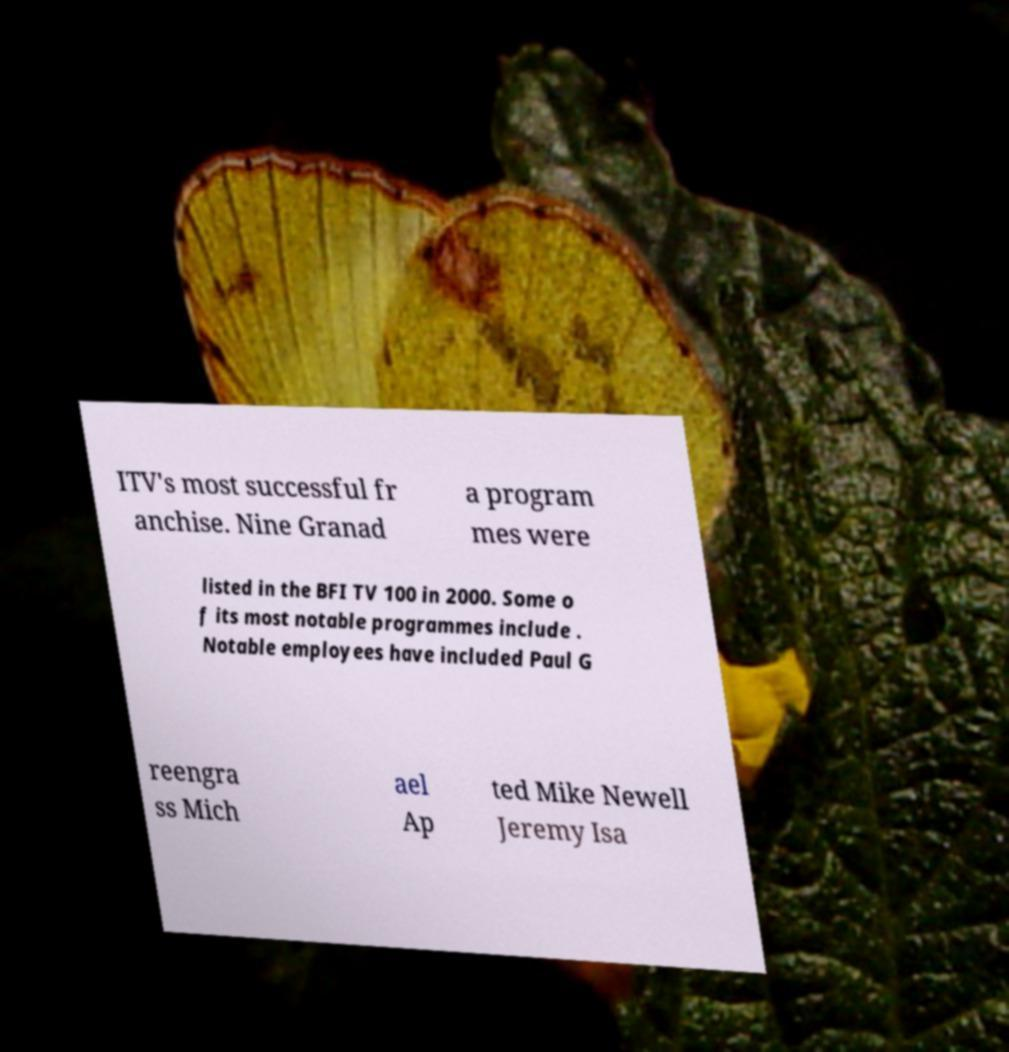Please read and relay the text visible in this image. What does it say? ITV's most successful fr anchise. Nine Granad a program mes were listed in the BFI TV 100 in 2000. Some o f its most notable programmes include . Notable employees have included Paul G reengra ss Mich ael Ap ted Mike Newell Jeremy Isa 